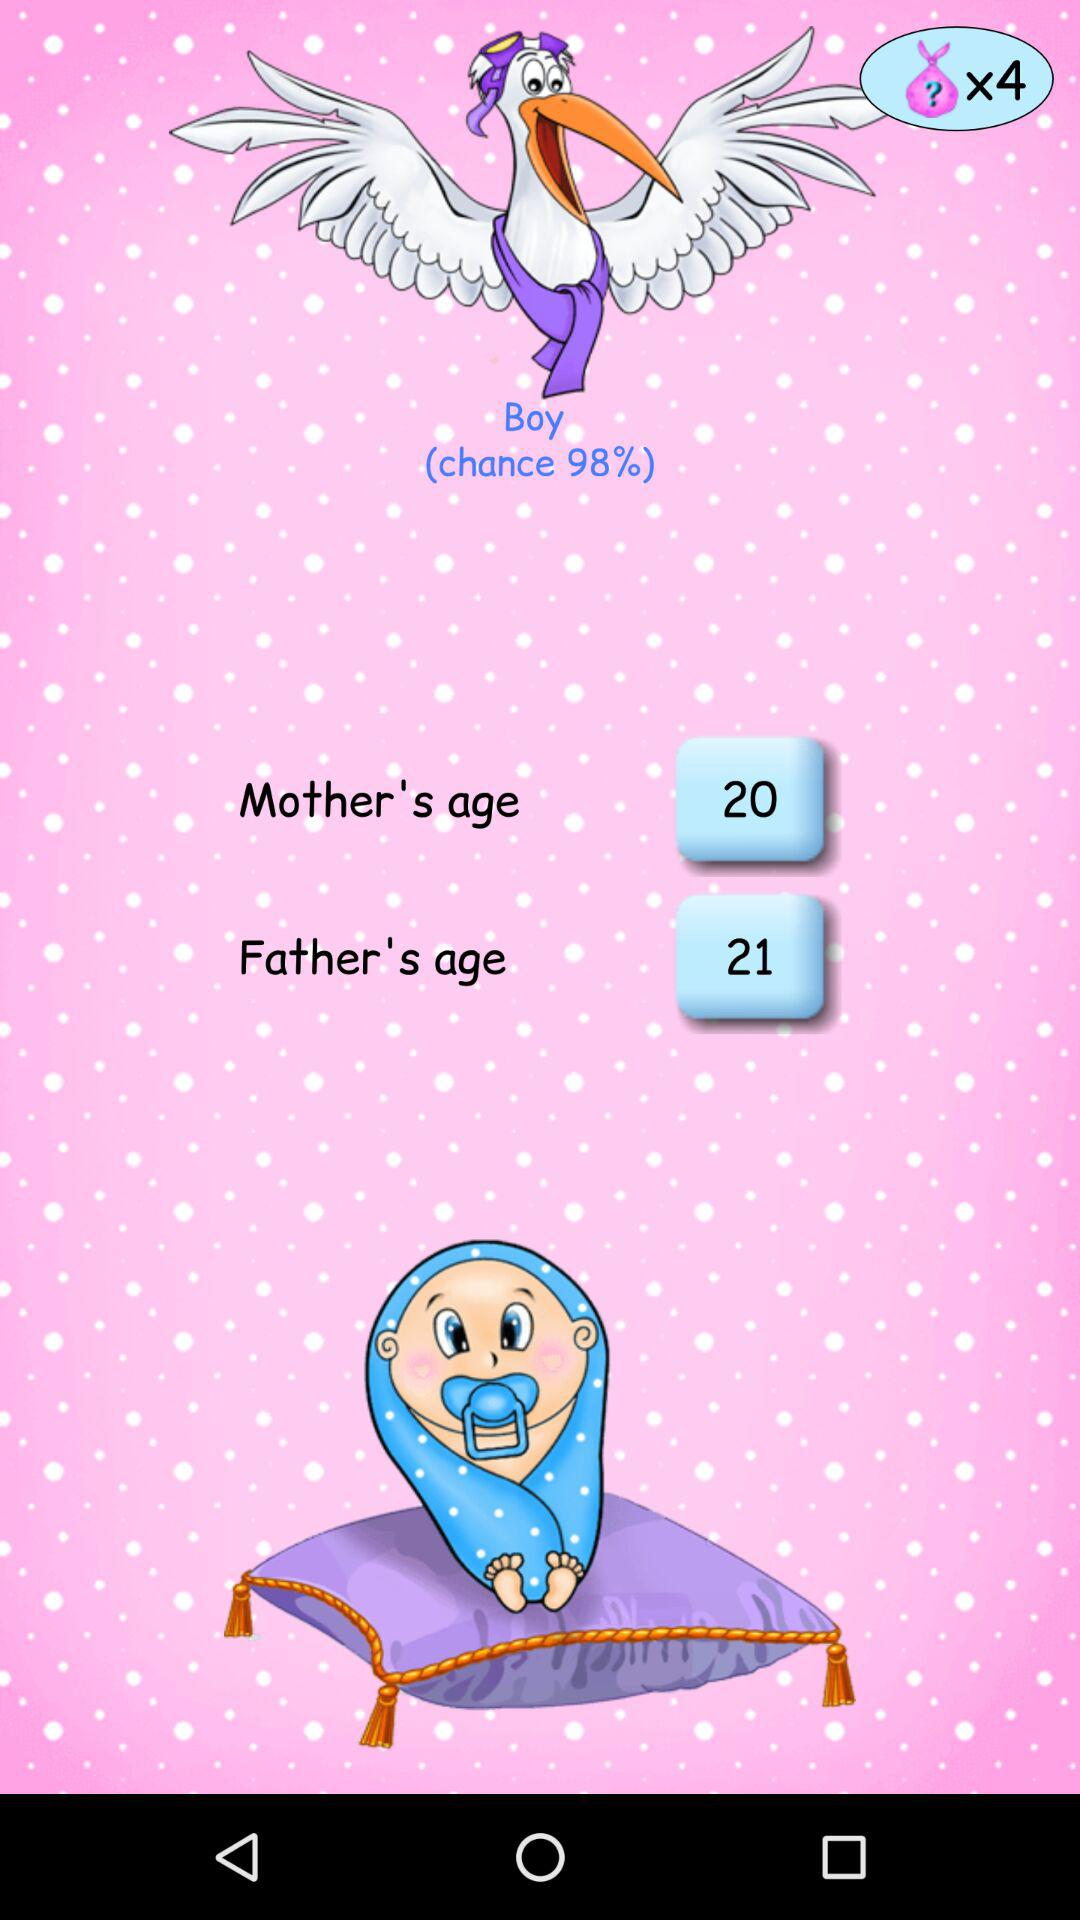What is the age of the mother? The age of the mother is 20. 